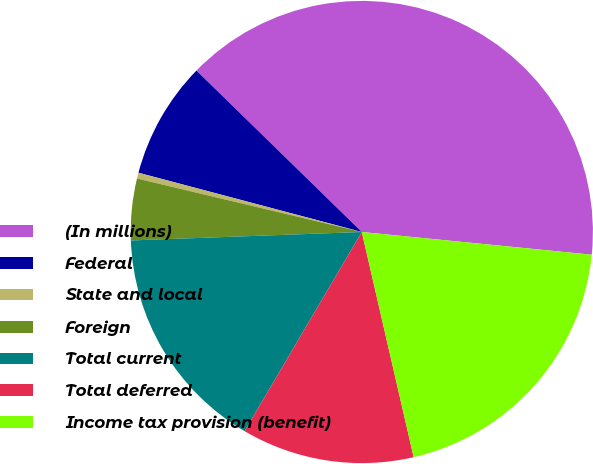<chart> <loc_0><loc_0><loc_500><loc_500><pie_chart><fcel>(In millions)<fcel>Federal<fcel>State and local<fcel>Foreign<fcel>Total current<fcel>Total deferred<fcel>Income tax provision (benefit)<nl><fcel>39.26%<fcel>8.18%<fcel>0.41%<fcel>4.3%<fcel>15.95%<fcel>12.07%<fcel>19.83%<nl></chart> 